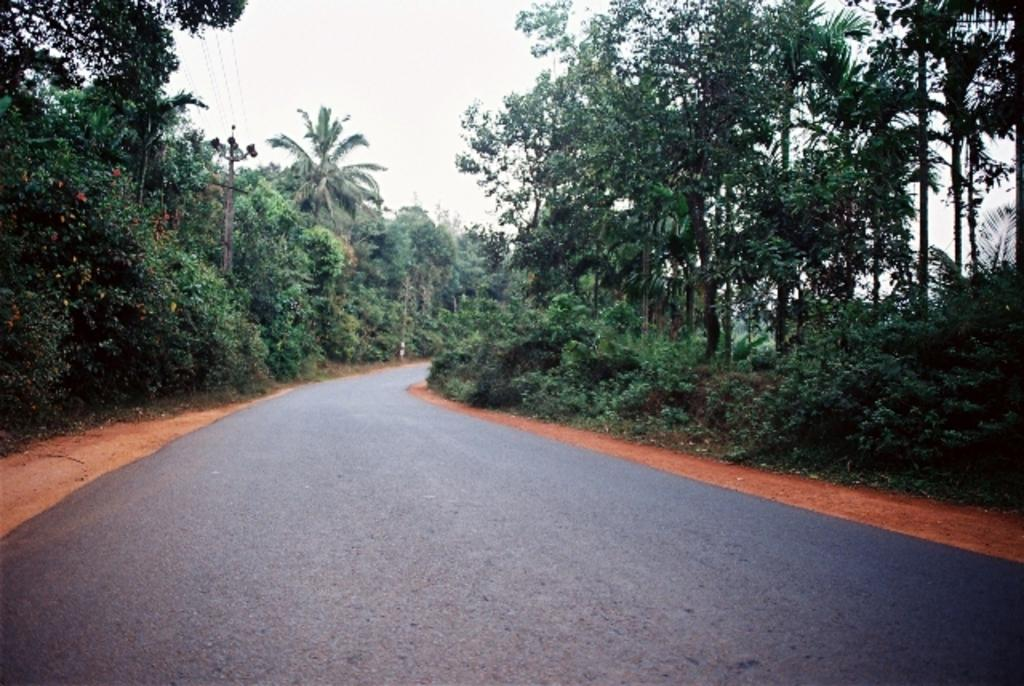What is the main feature of the image? There is a road in the image. What can be seen beside the road? There are trees beside the road. What other object is present in the image? There is a current pole in the image. What is visible above the road and trees? The sky is visible in the image. What letters are visible on the current pole in the image? There are no letters visible on the current pole in the image. 